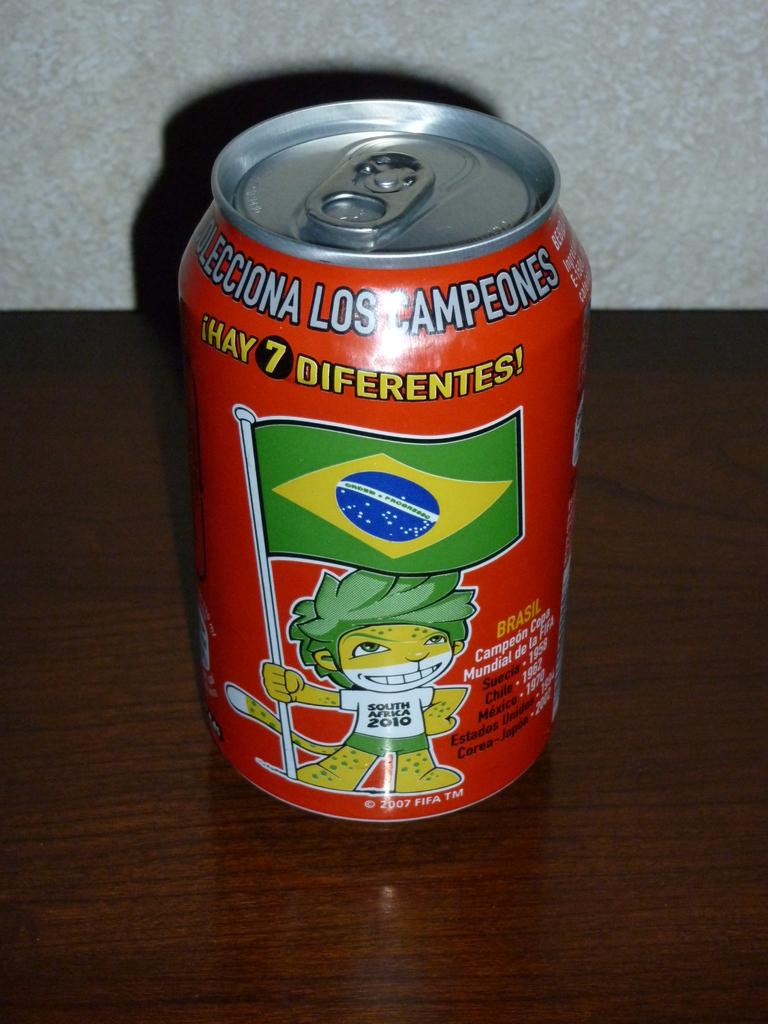What year is written on the character's shirt?
Provide a short and direct response. 2010. 